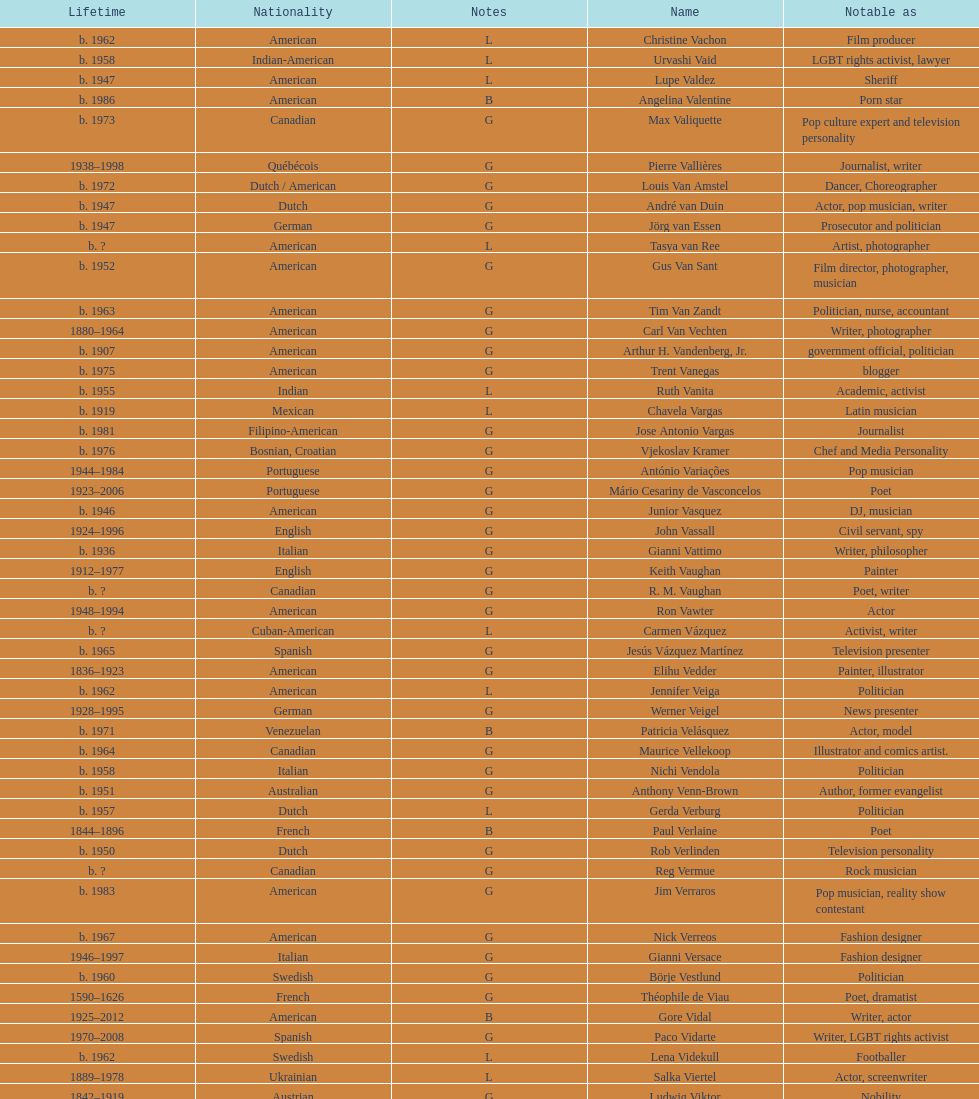Patricia velasquez and ron vawter both had what career? Actor. 